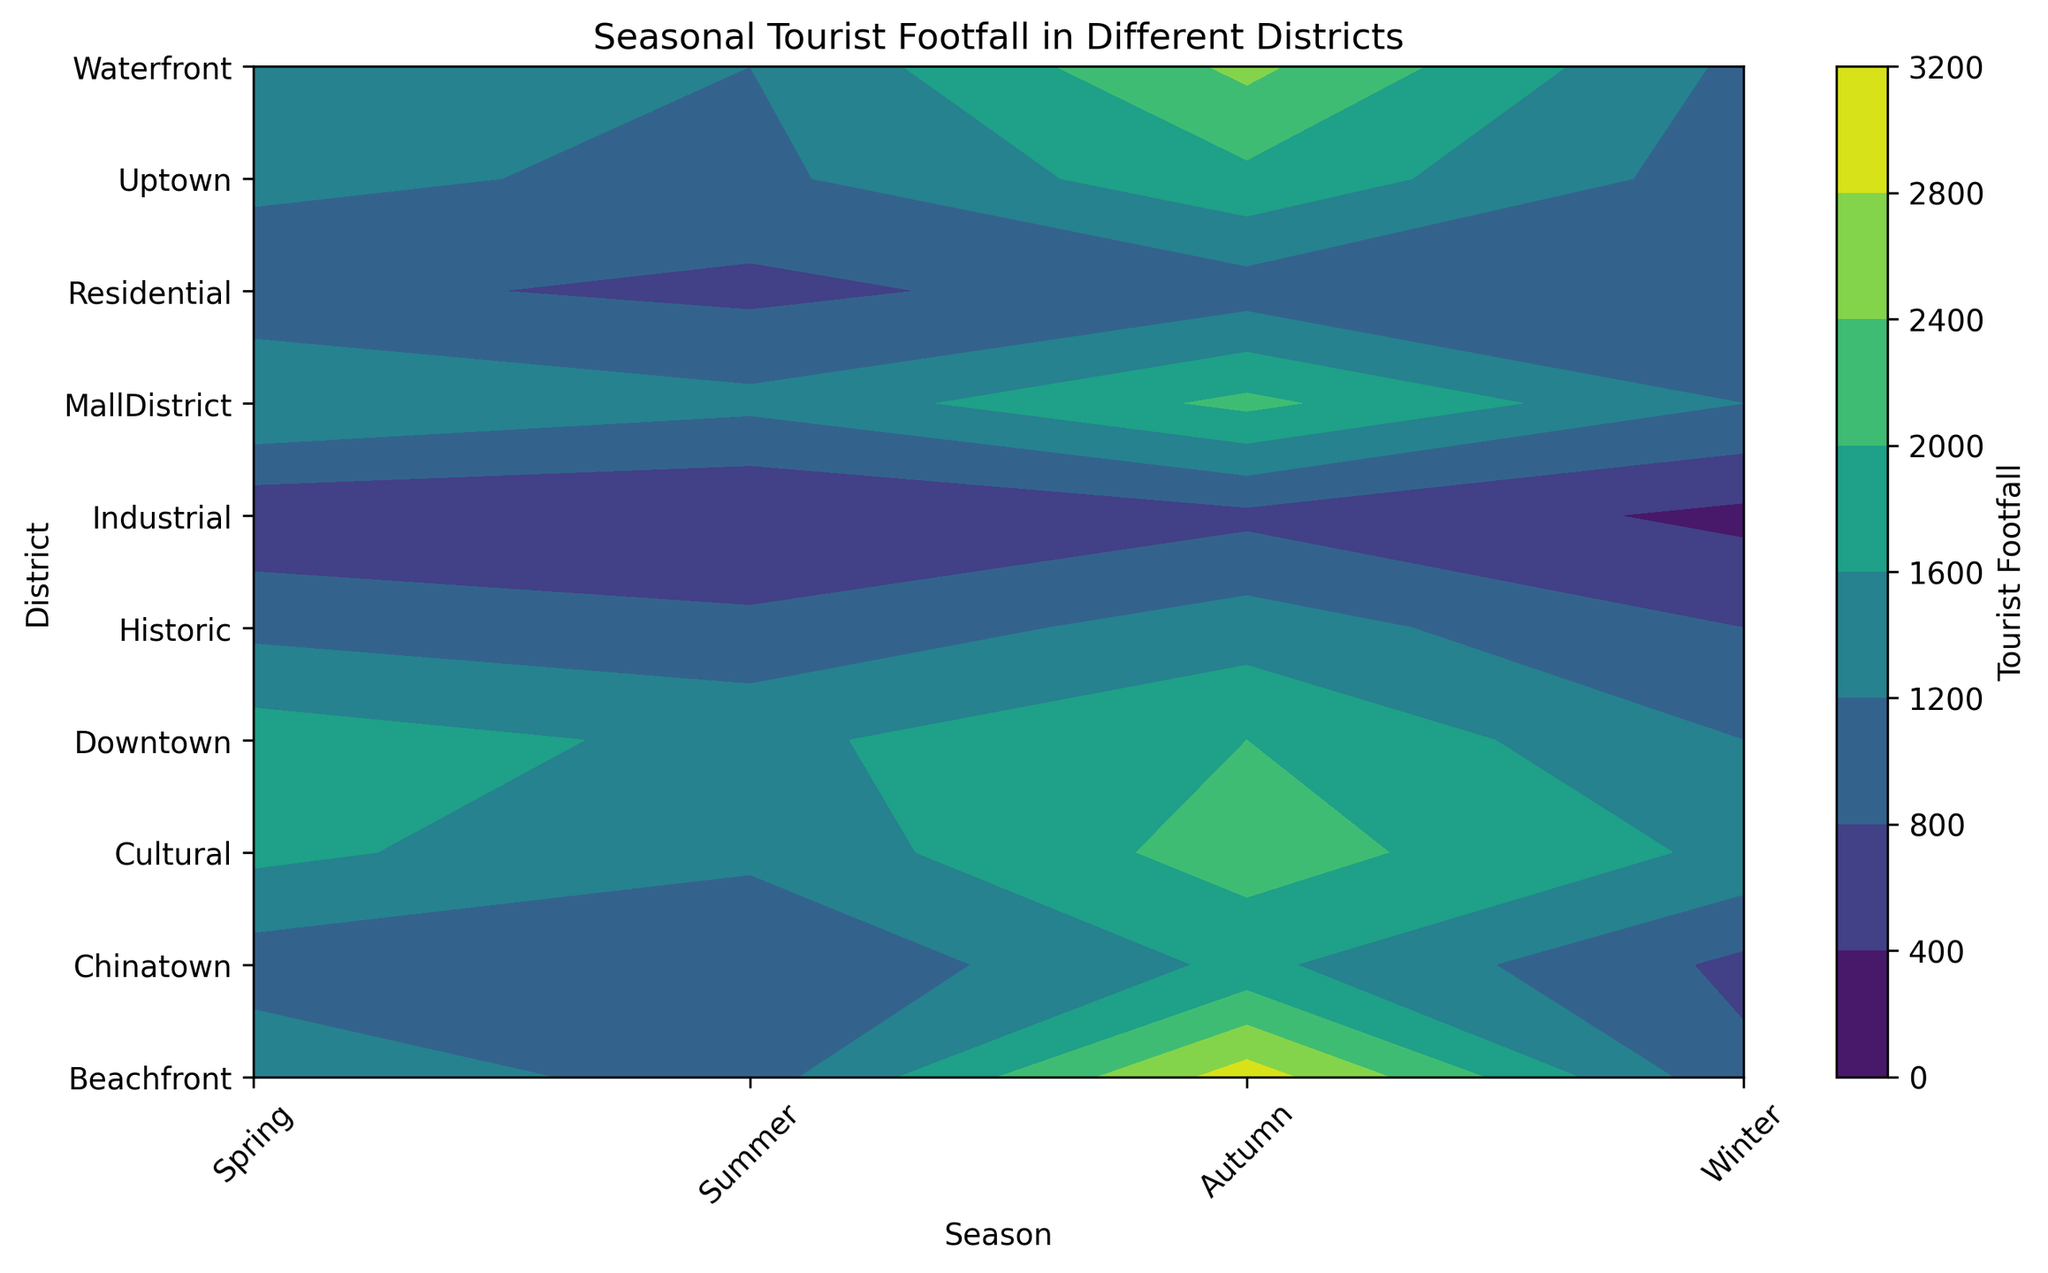Which district has the highest tourist footfall in summer? Looking at the figure, locate the x-axis label "Summer" and identify the district with the darkest color in this column. The darkest color, indicating highest footfall, is seen in the "Beachfront" district.
Answer: Beachfront What is the difference in tourist footfall between Downtown and Uptown in spring? Find the strip that represents "Spring" season. Compare the shades of "Downtown" and "Uptown" districts. From the legend or color bar, note the values corresponding to each shade. Downtown has a footfall of 1500, and Uptown has 1100. Subtracting these two values: 1500 - 1100 = 400.
Answer: 400 Which season has the least tourist footfall in the Industrial district? Look up the row labeled "Industrial" across all seasons and identify the lightest shade. The lightest shade corresponds to the lowest footfall value, which is in "Winter".
Answer: Winter How does the tourist footfall in Cultural district during Autumn compare to Waterfront district during Winter? Compare the shade/color intensity for "Cultural" in "Autumn" and "Waterfront" in "Winter". Using the legend, Cultural in Autumn is 1700 and Waterfront in Winter is 1100. Thus, 1700 > 1100.
Answer: Cultural in Autumn has higher footfall What is the average tourist footfall in the Residential district across all seasons? Sum the tourist footfall values for all seasons in the "Residential" district from the color shades: (Spring 700 + Summer 1000 + Autumn 900 + Winter 800). Divide the total by the number of seasons, 4. The calculation is: (700 + 1000 + 900 + 800) / 4 = 3400 / 4 = 850.
Answer: 850 In which district does the tourist footfall increase the most from Spring to Summer? Compare the footfall values at "Spring" and "Summer" across all districts from the color gradient. Beachfront footfall increases from 1000 in Spring to 3000 in Summer, an increase of 2000. This is the largest increase among all districts.
Answer: Beachfront Does the Historic district experience higher footfall in Winter or Spring? Locate "Historic" district and compare the shades for "Winter" and "Spring". The shade in "Spring" (900) is darker than in "Winter" (800), meaning Spring has higher footfall.
Answer: Spring Which districts have a footfall less than 1000 in any season? Look across each season for districts with very light color shades that correspond to footfall values below 1000. Identified districts include: Historic (Winter), Residential (Spring, Autumn, Winter), Industrial (all seasons), and Chinatown (Spring, Winter).
Answer: Historic, Residential, Industrial, Chinatown 